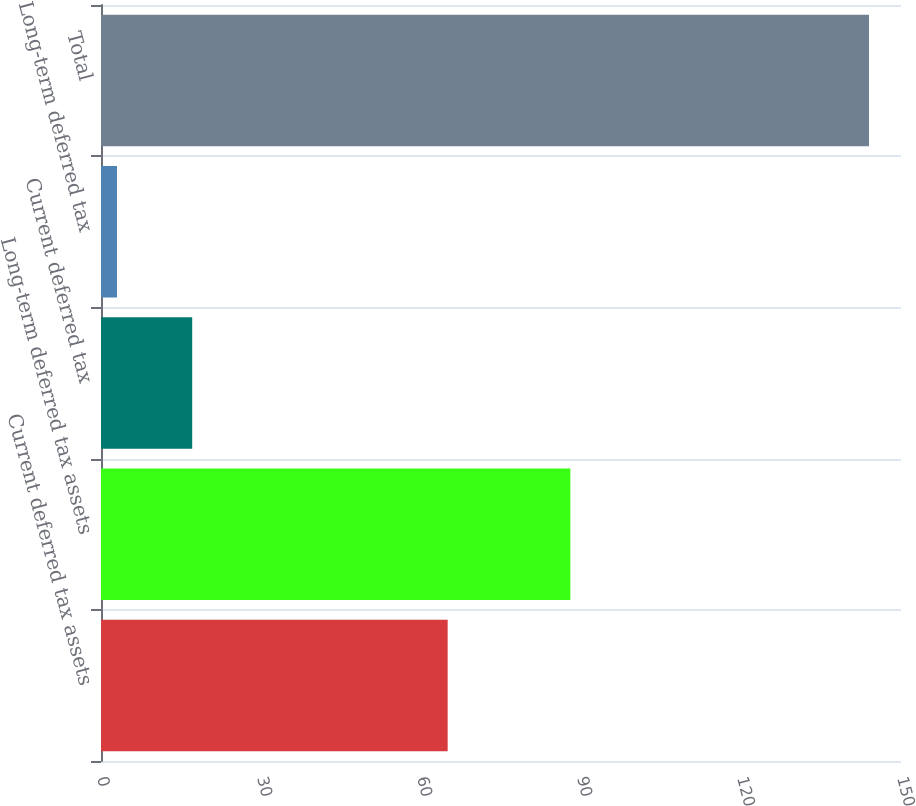Convert chart. <chart><loc_0><loc_0><loc_500><loc_500><bar_chart><fcel>Current deferred tax assets<fcel>Long-term deferred tax assets<fcel>Current deferred tax<fcel>Long-term deferred tax<fcel>Total<nl><fcel>65<fcel>88<fcel>17.1<fcel>3<fcel>144<nl></chart> 